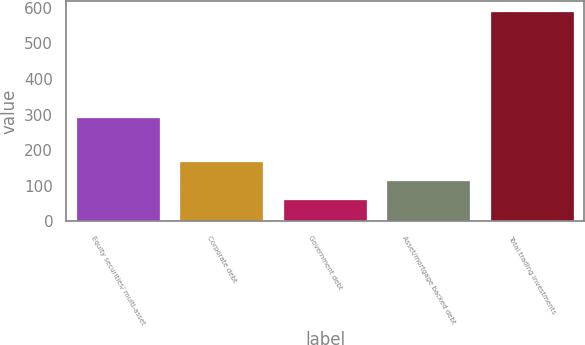<chart> <loc_0><loc_0><loc_500><loc_500><bar_chart><fcel>Equity securities/ multi-asset<fcel>Corporate debt<fcel>Government debt<fcel>Asset/mortgage backed debt<fcel>Total trading investments<nl><fcel>290<fcel>165.8<fcel>60<fcel>112.9<fcel>589<nl></chart> 